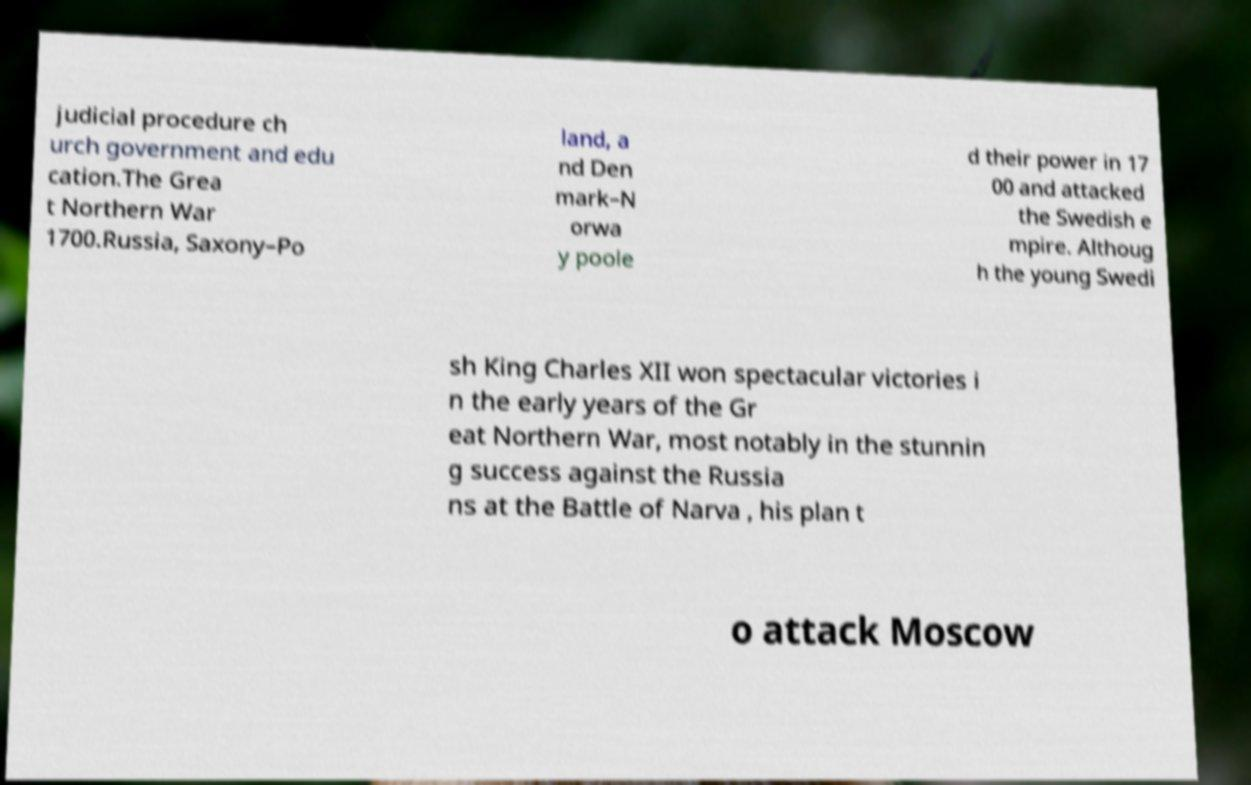What messages or text are displayed in this image? I need them in a readable, typed format. judicial procedure ch urch government and edu cation.The Grea t Northern War 1700.Russia, Saxony–Po land, a nd Den mark–N orwa y poole d their power in 17 00 and attacked the Swedish e mpire. Althoug h the young Swedi sh King Charles XII won spectacular victories i n the early years of the Gr eat Northern War, most notably in the stunnin g success against the Russia ns at the Battle of Narva , his plan t o attack Moscow 